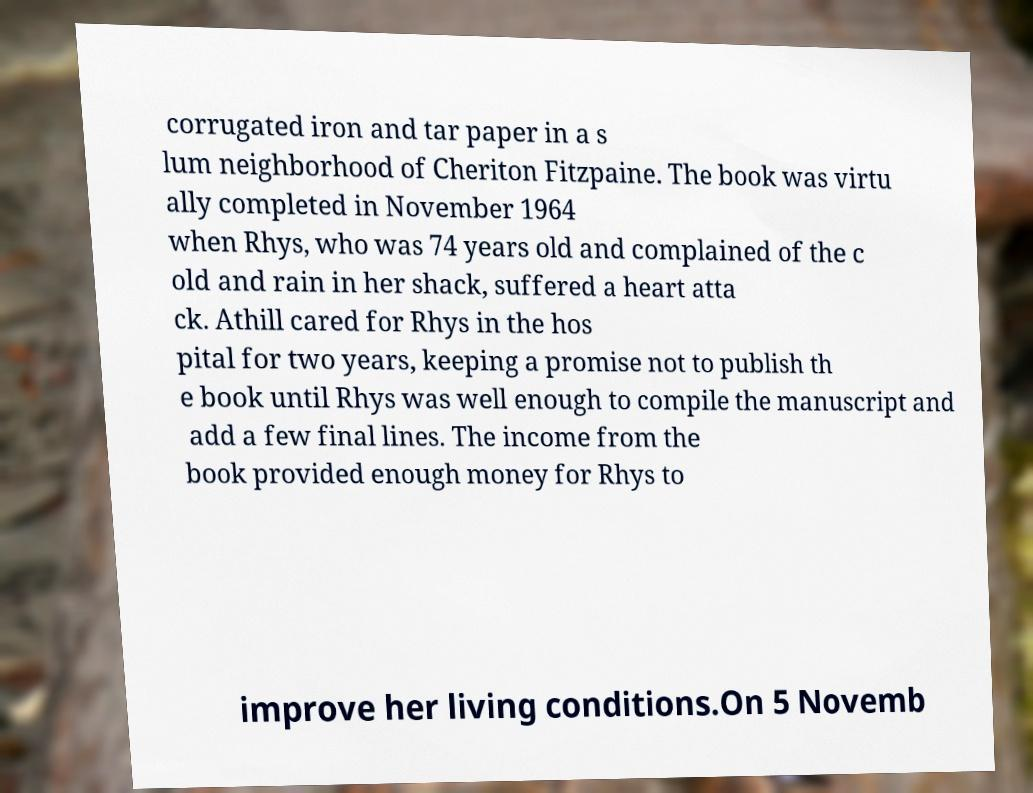I need the written content from this picture converted into text. Can you do that? corrugated iron and tar paper in a s lum neighborhood of Cheriton Fitzpaine. The book was virtu ally completed in November 1964 when Rhys, who was 74 years old and complained of the c old and rain in her shack, suffered a heart atta ck. Athill cared for Rhys in the hos pital for two years, keeping a promise not to publish th e book until Rhys was well enough to compile the manuscript and add a few final lines. The income from the book provided enough money for Rhys to improve her living conditions.On 5 Novemb 